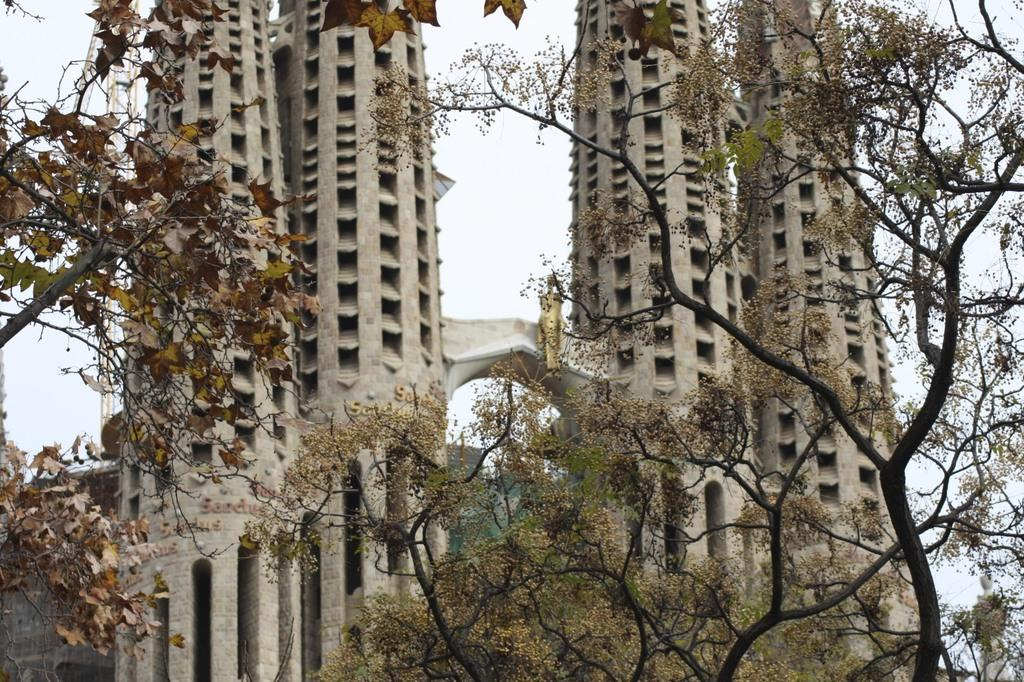What type of structures can be seen in the image? There are buildings in the image. What type of vegetation is visible in the image? There are trees in the image. What part of the natural environment is visible in the image? The sky is visible in the image. How many bags can be seen hanging from the trees in the image? There are no bags hanging from the trees in the image. Can you tell me how many people are visible in the image? There is no reference to any people in the image, so it cannot be determined from the picture. 